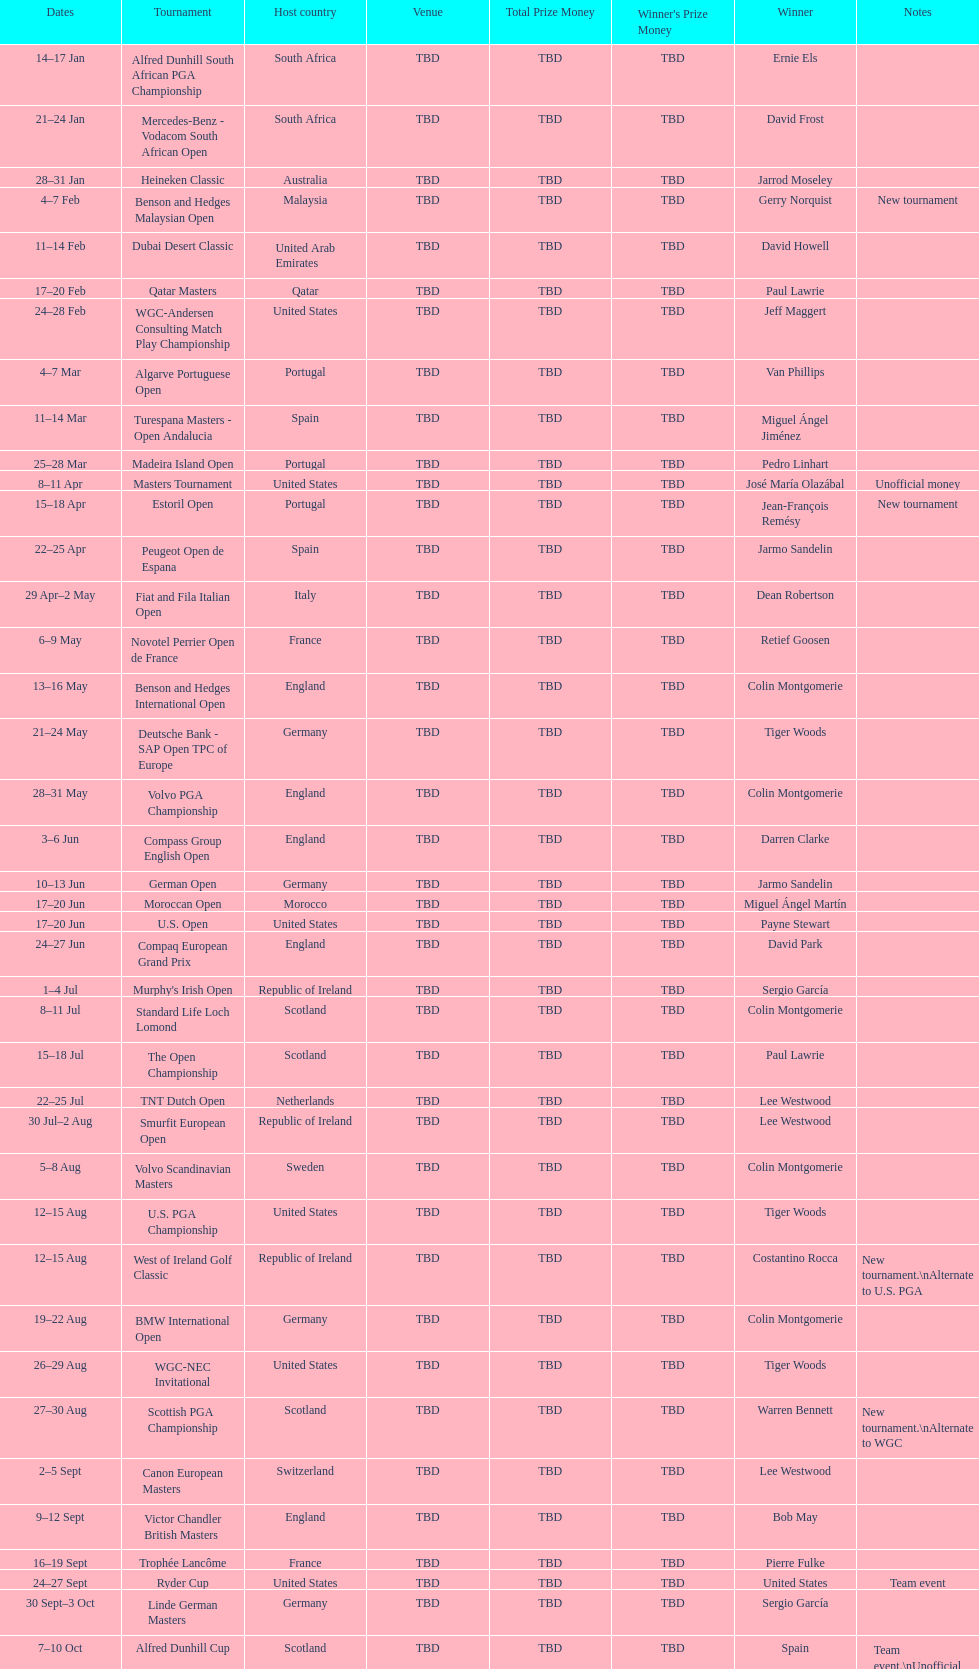Which winner won more tournaments, jeff maggert or tiger woods? Tiger Woods. 